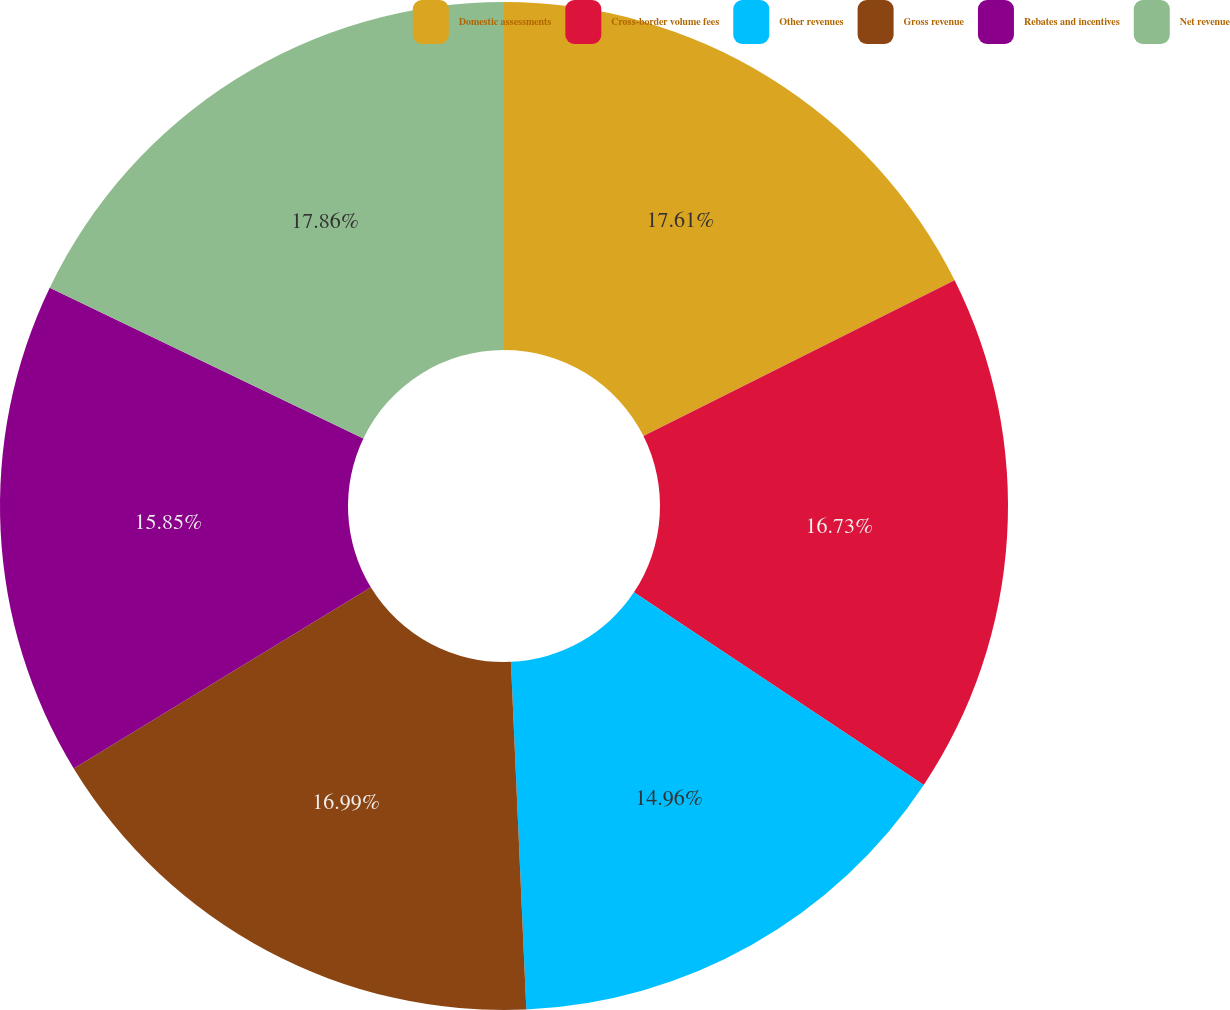<chart> <loc_0><loc_0><loc_500><loc_500><pie_chart><fcel>Domestic assessments<fcel>Cross-border volume fees<fcel>Other revenues<fcel>Gross revenue<fcel>Rebates and incentives<fcel>Net revenue<nl><fcel>17.61%<fcel>16.73%<fcel>14.96%<fcel>16.99%<fcel>15.85%<fcel>17.87%<nl></chart> 